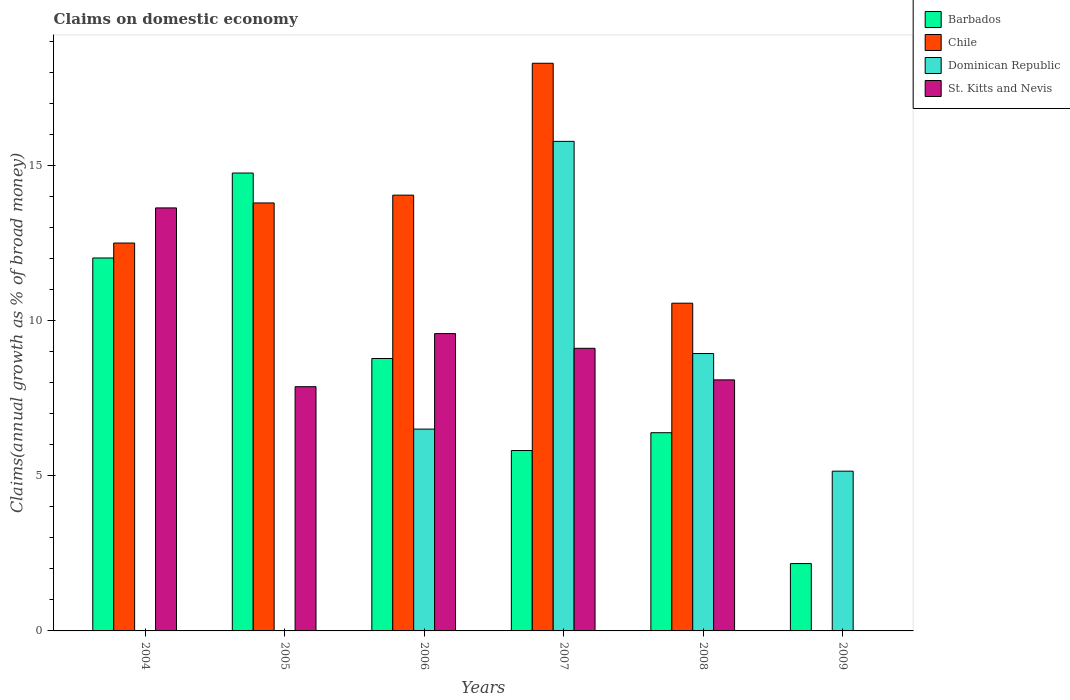Are the number of bars per tick equal to the number of legend labels?
Your answer should be compact. No. How many bars are there on the 5th tick from the left?
Provide a short and direct response. 4. How many bars are there on the 5th tick from the right?
Keep it short and to the point. 3. What is the percentage of broad money claimed on domestic economy in Barbados in 2004?
Ensure brevity in your answer.  12.03. Across all years, what is the maximum percentage of broad money claimed on domestic economy in St. Kitts and Nevis?
Give a very brief answer. 13.65. In which year was the percentage of broad money claimed on domestic economy in Dominican Republic maximum?
Your response must be concise. 2007. What is the total percentage of broad money claimed on domestic economy in Dominican Republic in the graph?
Offer a terse response. 36.4. What is the difference between the percentage of broad money claimed on domestic economy in Dominican Republic in 2007 and that in 2008?
Give a very brief answer. 6.84. What is the difference between the percentage of broad money claimed on domestic economy in Barbados in 2008 and the percentage of broad money claimed on domestic economy in Dominican Republic in 2009?
Provide a succinct answer. 1.24. What is the average percentage of broad money claimed on domestic economy in St. Kitts and Nevis per year?
Ensure brevity in your answer.  8.06. In the year 2004, what is the difference between the percentage of broad money claimed on domestic economy in Barbados and percentage of broad money claimed on domestic economy in Chile?
Ensure brevity in your answer.  -0.48. In how many years, is the percentage of broad money claimed on domestic economy in Dominican Republic greater than 2 %?
Ensure brevity in your answer.  4. What is the ratio of the percentage of broad money claimed on domestic economy in Chile in 2007 to that in 2008?
Offer a terse response. 1.73. Is the difference between the percentage of broad money claimed on domestic economy in Barbados in 2004 and 2005 greater than the difference between the percentage of broad money claimed on domestic economy in Chile in 2004 and 2005?
Provide a short and direct response. No. What is the difference between the highest and the second highest percentage of broad money claimed on domestic economy in St. Kitts and Nevis?
Your response must be concise. 4.05. What is the difference between the highest and the lowest percentage of broad money claimed on domestic economy in Barbados?
Offer a terse response. 12.6. In how many years, is the percentage of broad money claimed on domestic economy in Chile greater than the average percentage of broad money claimed on domestic economy in Chile taken over all years?
Give a very brief answer. 4. How many years are there in the graph?
Provide a succinct answer. 6. Are the values on the major ticks of Y-axis written in scientific E-notation?
Offer a terse response. No. Does the graph contain grids?
Make the answer very short. No. How many legend labels are there?
Your response must be concise. 4. What is the title of the graph?
Offer a terse response. Claims on domestic economy. Does "Thailand" appear as one of the legend labels in the graph?
Your response must be concise. No. What is the label or title of the X-axis?
Provide a succinct answer. Years. What is the label or title of the Y-axis?
Provide a short and direct response. Claims(annual growth as % of broad money). What is the Claims(annual growth as % of broad money) of Barbados in 2004?
Offer a terse response. 12.03. What is the Claims(annual growth as % of broad money) in Chile in 2004?
Provide a succinct answer. 12.51. What is the Claims(annual growth as % of broad money) in Dominican Republic in 2004?
Ensure brevity in your answer.  0. What is the Claims(annual growth as % of broad money) in St. Kitts and Nevis in 2004?
Your response must be concise. 13.65. What is the Claims(annual growth as % of broad money) in Barbados in 2005?
Give a very brief answer. 14.77. What is the Claims(annual growth as % of broad money) in Chile in 2005?
Offer a very short reply. 13.81. What is the Claims(annual growth as % of broad money) in St. Kitts and Nevis in 2005?
Make the answer very short. 7.88. What is the Claims(annual growth as % of broad money) in Barbados in 2006?
Give a very brief answer. 8.79. What is the Claims(annual growth as % of broad money) of Chile in 2006?
Keep it short and to the point. 14.06. What is the Claims(annual growth as % of broad money) in Dominican Republic in 2006?
Make the answer very short. 6.51. What is the Claims(annual growth as % of broad money) of St. Kitts and Nevis in 2006?
Provide a succinct answer. 9.59. What is the Claims(annual growth as % of broad money) of Barbados in 2007?
Your answer should be very brief. 5.82. What is the Claims(annual growth as % of broad money) of Chile in 2007?
Offer a very short reply. 18.31. What is the Claims(annual growth as % of broad money) of Dominican Republic in 2007?
Provide a succinct answer. 15.79. What is the Claims(annual growth as % of broad money) of St. Kitts and Nevis in 2007?
Keep it short and to the point. 9.12. What is the Claims(annual growth as % of broad money) in Barbados in 2008?
Make the answer very short. 6.39. What is the Claims(annual growth as % of broad money) of Chile in 2008?
Offer a terse response. 10.57. What is the Claims(annual growth as % of broad money) of Dominican Republic in 2008?
Offer a terse response. 8.95. What is the Claims(annual growth as % of broad money) in St. Kitts and Nevis in 2008?
Keep it short and to the point. 8.1. What is the Claims(annual growth as % of broad money) in Barbados in 2009?
Offer a very short reply. 2.17. What is the Claims(annual growth as % of broad money) of Dominican Republic in 2009?
Make the answer very short. 5.15. What is the Claims(annual growth as % of broad money) of St. Kitts and Nevis in 2009?
Keep it short and to the point. 0. Across all years, what is the maximum Claims(annual growth as % of broad money) in Barbados?
Make the answer very short. 14.77. Across all years, what is the maximum Claims(annual growth as % of broad money) in Chile?
Offer a very short reply. 18.31. Across all years, what is the maximum Claims(annual growth as % of broad money) in Dominican Republic?
Ensure brevity in your answer.  15.79. Across all years, what is the maximum Claims(annual growth as % of broad money) in St. Kitts and Nevis?
Keep it short and to the point. 13.65. Across all years, what is the minimum Claims(annual growth as % of broad money) in Barbados?
Your answer should be compact. 2.17. Across all years, what is the minimum Claims(annual growth as % of broad money) of Dominican Republic?
Your answer should be very brief. 0. Across all years, what is the minimum Claims(annual growth as % of broad money) in St. Kitts and Nevis?
Your response must be concise. 0. What is the total Claims(annual growth as % of broad money) of Barbados in the graph?
Provide a short and direct response. 49.97. What is the total Claims(annual growth as % of broad money) of Chile in the graph?
Give a very brief answer. 69.26. What is the total Claims(annual growth as % of broad money) in Dominican Republic in the graph?
Ensure brevity in your answer.  36.4. What is the total Claims(annual growth as % of broad money) of St. Kitts and Nevis in the graph?
Ensure brevity in your answer.  48.33. What is the difference between the Claims(annual growth as % of broad money) of Barbados in 2004 and that in 2005?
Keep it short and to the point. -2.74. What is the difference between the Claims(annual growth as % of broad money) in Chile in 2004 and that in 2005?
Your response must be concise. -1.29. What is the difference between the Claims(annual growth as % of broad money) in St. Kitts and Nevis in 2004 and that in 2005?
Your answer should be very brief. 5.77. What is the difference between the Claims(annual growth as % of broad money) of Barbados in 2004 and that in 2006?
Provide a succinct answer. 3.24. What is the difference between the Claims(annual growth as % of broad money) in Chile in 2004 and that in 2006?
Give a very brief answer. -1.54. What is the difference between the Claims(annual growth as % of broad money) in St. Kitts and Nevis in 2004 and that in 2006?
Ensure brevity in your answer.  4.05. What is the difference between the Claims(annual growth as % of broad money) in Barbados in 2004 and that in 2007?
Keep it short and to the point. 6.21. What is the difference between the Claims(annual growth as % of broad money) of Chile in 2004 and that in 2007?
Make the answer very short. -5.8. What is the difference between the Claims(annual growth as % of broad money) in St. Kitts and Nevis in 2004 and that in 2007?
Your answer should be compact. 4.53. What is the difference between the Claims(annual growth as % of broad money) in Barbados in 2004 and that in 2008?
Provide a short and direct response. 5.64. What is the difference between the Claims(annual growth as % of broad money) of Chile in 2004 and that in 2008?
Provide a succinct answer. 1.94. What is the difference between the Claims(annual growth as % of broad money) of St. Kitts and Nevis in 2004 and that in 2008?
Ensure brevity in your answer.  5.55. What is the difference between the Claims(annual growth as % of broad money) of Barbados in 2004 and that in 2009?
Provide a short and direct response. 9.86. What is the difference between the Claims(annual growth as % of broad money) of Barbados in 2005 and that in 2006?
Give a very brief answer. 5.98. What is the difference between the Claims(annual growth as % of broad money) in Chile in 2005 and that in 2006?
Ensure brevity in your answer.  -0.25. What is the difference between the Claims(annual growth as % of broad money) of St. Kitts and Nevis in 2005 and that in 2006?
Give a very brief answer. -1.71. What is the difference between the Claims(annual growth as % of broad money) in Barbados in 2005 and that in 2007?
Offer a terse response. 8.95. What is the difference between the Claims(annual growth as % of broad money) of Chile in 2005 and that in 2007?
Your response must be concise. -4.51. What is the difference between the Claims(annual growth as % of broad money) in St. Kitts and Nevis in 2005 and that in 2007?
Give a very brief answer. -1.24. What is the difference between the Claims(annual growth as % of broad money) of Barbados in 2005 and that in 2008?
Give a very brief answer. 8.38. What is the difference between the Claims(annual growth as % of broad money) of Chile in 2005 and that in 2008?
Your answer should be very brief. 3.23. What is the difference between the Claims(annual growth as % of broad money) of St. Kitts and Nevis in 2005 and that in 2008?
Provide a short and direct response. -0.22. What is the difference between the Claims(annual growth as % of broad money) in Barbados in 2005 and that in 2009?
Offer a very short reply. 12.6. What is the difference between the Claims(annual growth as % of broad money) in Barbados in 2006 and that in 2007?
Your response must be concise. 2.97. What is the difference between the Claims(annual growth as % of broad money) in Chile in 2006 and that in 2007?
Provide a succinct answer. -4.25. What is the difference between the Claims(annual growth as % of broad money) of Dominican Republic in 2006 and that in 2007?
Your answer should be very brief. -9.28. What is the difference between the Claims(annual growth as % of broad money) of St. Kitts and Nevis in 2006 and that in 2007?
Provide a short and direct response. 0.47. What is the difference between the Claims(annual growth as % of broad money) of Barbados in 2006 and that in 2008?
Give a very brief answer. 2.39. What is the difference between the Claims(annual growth as % of broad money) of Chile in 2006 and that in 2008?
Keep it short and to the point. 3.49. What is the difference between the Claims(annual growth as % of broad money) of Dominican Republic in 2006 and that in 2008?
Make the answer very short. -2.44. What is the difference between the Claims(annual growth as % of broad money) in St. Kitts and Nevis in 2006 and that in 2008?
Provide a short and direct response. 1.49. What is the difference between the Claims(annual growth as % of broad money) of Barbados in 2006 and that in 2009?
Make the answer very short. 6.61. What is the difference between the Claims(annual growth as % of broad money) in Dominican Republic in 2006 and that in 2009?
Offer a terse response. 1.36. What is the difference between the Claims(annual growth as % of broad money) in Barbados in 2007 and that in 2008?
Make the answer very short. -0.57. What is the difference between the Claims(annual growth as % of broad money) of Chile in 2007 and that in 2008?
Ensure brevity in your answer.  7.74. What is the difference between the Claims(annual growth as % of broad money) in Dominican Republic in 2007 and that in 2008?
Your answer should be very brief. 6.84. What is the difference between the Claims(annual growth as % of broad money) in St. Kitts and Nevis in 2007 and that in 2008?
Provide a succinct answer. 1.02. What is the difference between the Claims(annual growth as % of broad money) in Barbados in 2007 and that in 2009?
Make the answer very short. 3.65. What is the difference between the Claims(annual growth as % of broad money) in Dominican Republic in 2007 and that in 2009?
Your answer should be very brief. 10.64. What is the difference between the Claims(annual growth as % of broad money) in Barbados in 2008 and that in 2009?
Your answer should be compact. 4.22. What is the difference between the Claims(annual growth as % of broad money) of Dominican Republic in 2008 and that in 2009?
Ensure brevity in your answer.  3.79. What is the difference between the Claims(annual growth as % of broad money) in Barbados in 2004 and the Claims(annual growth as % of broad money) in Chile in 2005?
Ensure brevity in your answer.  -1.78. What is the difference between the Claims(annual growth as % of broad money) in Barbados in 2004 and the Claims(annual growth as % of broad money) in St. Kitts and Nevis in 2005?
Keep it short and to the point. 4.15. What is the difference between the Claims(annual growth as % of broad money) in Chile in 2004 and the Claims(annual growth as % of broad money) in St. Kitts and Nevis in 2005?
Provide a succinct answer. 4.63. What is the difference between the Claims(annual growth as % of broad money) in Barbados in 2004 and the Claims(annual growth as % of broad money) in Chile in 2006?
Provide a succinct answer. -2.03. What is the difference between the Claims(annual growth as % of broad money) in Barbados in 2004 and the Claims(annual growth as % of broad money) in Dominican Republic in 2006?
Keep it short and to the point. 5.52. What is the difference between the Claims(annual growth as % of broad money) of Barbados in 2004 and the Claims(annual growth as % of broad money) of St. Kitts and Nevis in 2006?
Ensure brevity in your answer.  2.44. What is the difference between the Claims(annual growth as % of broad money) in Chile in 2004 and the Claims(annual growth as % of broad money) in Dominican Republic in 2006?
Keep it short and to the point. 6. What is the difference between the Claims(annual growth as % of broad money) in Chile in 2004 and the Claims(annual growth as % of broad money) in St. Kitts and Nevis in 2006?
Keep it short and to the point. 2.92. What is the difference between the Claims(annual growth as % of broad money) of Barbados in 2004 and the Claims(annual growth as % of broad money) of Chile in 2007?
Provide a succinct answer. -6.28. What is the difference between the Claims(annual growth as % of broad money) of Barbados in 2004 and the Claims(annual growth as % of broad money) of Dominican Republic in 2007?
Your response must be concise. -3.76. What is the difference between the Claims(annual growth as % of broad money) of Barbados in 2004 and the Claims(annual growth as % of broad money) of St. Kitts and Nevis in 2007?
Keep it short and to the point. 2.91. What is the difference between the Claims(annual growth as % of broad money) in Chile in 2004 and the Claims(annual growth as % of broad money) in Dominican Republic in 2007?
Provide a short and direct response. -3.28. What is the difference between the Claims(annual growth as % of broad money) in Chile in 2004 and the Claims(annual growth as % of broad money) in St. Kitts and Nevis in 2007?
Ensure brevity in your answer.  3.4. What is the difference between the Claims(annual growth as % of broad money) of Barbados in 2004 and the Claims(annual growth as % of broad money) of Chile in 2008?
Your answer should be compact. 1.46. What is the difference between the Claims(annual growth as % of broad money) in Barbados in 2004 and the Claims(annual growth as % of broad money) in Dominican Republic in 2008?
Your answer should be compact. 3.08. What is the difference between the Claims(annual growth as % of broad money) of Barbados in 2004 and the Claims(annual growth as % of broad money) of St. Kitts and Nevis in 2008?
Offer a terse response. 3.93. What is the difference between the Claims(annual growth as % of broad money) in Chile in 2004 and the Claims(annual growth as % of broad money) in Dominican Republic in 2008?
Offer a very short reply. 3.56. What is the difference between the Claims(annual growth as % of broad money) in Chile in 2004 and the Claims(annual growth as % of broad money) in St. Kitts and Nevis in 2008?
Your answer should be very brief. 4.41. What is the difference between the Claims(annual growth as % of broad money) of Barbados in 2004 and the Claims(annual growth as % of broad money) of Dominican Republic in 2009?
Provide a succinct answer. 6.88. What is the difference between the Claims(annual growth as % of broad money) of Chile in 2004 and the Claims(annual growth as % of broad money) of Dominican Republic in 2009?
Your answer should be compact. 7.36. What is the difference between the Claims(annual growth as % of broad money) of Barbados in 2005 and the Claims(annual growth as % of broad money) of Chile in 2006?
Keep it short and to the point. 0.71. What is the difference between the Claims(annual growth as % of broad money) in Barbados in 2005 and the Claims(annual growth as % of broad money) in Dominican Republic in 2006?
Offer a terse response. 8.26. What is the difference between the Claims(annual growth as % of broad money) in Barbados in 2005 and the Claims(annual growth as % of broad money) in St. Kitts and Nevis in 2006?
Your response must be concise. 5.18. What is the difference between the Claims(annual growth as % of broad money) of Chile in 2005 and the Claims(annual growth as % of broad money) of Dominican Republic in 2006?
Your response must be concise. 7.3. What is the difference between the Claims(annual growth as % of broad money) of Chile in 2005 and the Claims(annual growth as % of broad money) of St. Kitts and Nevis in 2006?
Offer a terse response. 4.21. What is the difference between the Claims(annual growth as % of broad money) of Barbados in 2005 and the Claims(annual growth as % of broad money) of Chile in 2007?
Give a very brief answer. -3.54. What is the difference between the Claims(annual growth as % of broad money) in Barbados in 2005 and the Claims(annual growth as % of broad money) in Dominican Republic in 2007?
Your answer should be compact. -1.02. What is the difference between the Claims(annual growth as % of broad money) of Barbados in 2005 and the Claims(annual growth as % of broad money) of St. Kitts and Nevis in 2007?
Provide a succinct answer. 5.65. What is the difference between the Claims(annual growth as % of broad money) of Chile in 2005 and the Claims(annual growth as % of broad money) of Dominican Republic in 2007?
Give a very brief answer. -1.99. What is the difference between the Claims(annual growth as % of broad money) in Chile in 2005 and the Claims(annual growth as % of broad money) in St. Kitts and Nevis in 2007?
Provide a short and direct response. 4.69. What is the difference between the Claims(annual growth as % of broad money) in Barbados in 2005 and the Claims(annual growth as % of broad money) in Chile in 2008?
Make the answer very short. 4.2. What is the difference between the Claims(annual growth as % of broad money) in Barbados in 2005 and the Claims(annual growth as % of broad money) in Dominican Republic in 2008?
Ensure brevity in your answer.  5.82. What is the difference between the Claims(annual growth as % of broad money) of Barbados in 2005 and the Claims(annual growth as % of broad money) of St. Kitts and Nevis in 2008?
Offer a terse response. 6.67. What is the difference between the Claims(annual growth as % of broad money) of Chile in 2005 and the Claims(annual growth as % of broad money) of Dominican Republic in 2008?
Give a very brief answer. 4.86. What is the difference between the Claims(annual growth as % of broad money) of Chile in 2005 and the Claims(annual growth as % of broad money) of St. Kitts and Nevis in 2008?
Provide a succinct answer. 5.71. What is the difference between the Claims(annual growth as % of broad money) in Barbados in 2005 and the Claims(annual growth as % of broad money) in Dominican Republic in 2009?
Offer a terse response. 9.62. What is the difference between the Claims(annual growth as % of broad money) of Chile in 2005 and the Claims(annual growth as % of broad money) of Dominican Republic in 2009?
Offer a very short reply. 8.65. What is the difference between the Claims(annual growth as % of broad money) in Barbados in 2006 and the Claims(annual growth as % of broad money) in Chile in 2007?
Your response must be concise. -9.52. What is the difference between the Claims(annual growth as % of broad money) in Barbados in 2006 and the Claims(annual growth as % of broad money) in Dominican Republic in 2007?
Ensure brevity in your answer.  -7. What is the difference between the Claims(annual growth as % of broad money) of Barbados in 2006 and the Claims(annual growth as % of broad money) of St. Kitts and Nevis in 2007?
Your answer should be very brief. -0.33. What is the difference between the Claims(annual growth as % of broad money) of Chile in 2006 and the Claims(annual growth as % of broad money) of Dominican Republic in 2007?
Ensure brevity in your answer.  -1.73. What is the difference between the Claims(annual growth as % of broad money) in Chile in 2006 and the Claims(annual growth as % of broad money) in St. Kitts and Nevis in 2007?
Make the answer very short. 4.94. What is the difference between the Claims(annual growth as % of broad money) of Dominican Republic in 2006 and the Claims(annual growth as % of broad money) of St. Kitts and Nevis in 2007?
Your answer should be very brief. -2.61. What is the difference between the Claims(annual growth as % of broad money) of Barbados in 2006 and the Claims(annual growth as % of broad money) of Chile in 2008?
Provide a short and direct response. -1.78. What is the difference between the Claims(annual growth as % of broad money) in Barbados in 2006 and the Claims(annual growth as % of broad money) in Dominican Republic in 2008?
Give a very brief answer. -0.16. What is the difference between the Claims(annual growth as % of broad money) of Barbados in 2006 and the Claims(annual growth as % of broad money) of St. Kitts and Nevis in 2008?
Provide a succinct answer. 0.69. What is the difference between the Claims(annual growth as % of broad money) in Chile in 2006 and the Claims(annual growth as % of broad money) in Dominican Republic in 2008?
Your response must be concise. 5.11. What is the difference between the Claims(annual growth as % of broad money) of Chile in 2006 and the Claims(annual growth as % of broad money) of St. Kitts and Nevis in 2008?
Provide a succinct answer. 5.96. What is the difference between the Claims(annual growth as % of broad money) of Dominican Republic in 2006 and the Claims(annual growth as % of broad money) of St. Kitts and Nevis in 2008?
Make the answer very short. -1.59. What is the difference between the Claims(annual growth as % of broad money) in Barbados in 2006 and the Claims(annual growth as % of broad money) in Dominican Republic in 2009?
Make the answer very short. 3.63. What is the difference between the Claims(annual growth as % of broad money) of Chile in 2006 and the Claims(annual growth as % of broad money) of Dominican Republic in 2009?
Ensure brevity in your answer.  8.9. What is the difference between the Claims(annual growth as % of broad money) in Barbados in 2007 and the Claims(annual growth as % of broad money) in Chile in 2008?
Provide a short and direct response. -4.75. What is the difference between the Claims(annual growth as % of broad money) of Barbados in 2007 and the Claims(annual growth as % of broad money) of Dominican Republic in 2008?
Make the answer very short. -3.13. What is the difference between the Claims(annual growth as % of broad money) in Barbados in 2007 and the Claims(annual growth as % of broad money) in St. Kitts and Nevis in 2008?
Your answer should be compact. -2.28. What is the difference between the Claims(annual growth as % of broad money) of Chile in 2007 and the Claims(annual growth as % of broad money) of Dominican Republic in 2008?
Make the answer very short. 9.36. What is the difference between the Claims(annual growth as % of broad money) in Chile in 2007 and the Claims(annual growth as % of broad money) in St. Kitts and Nevis in 2008?
Give a very brief answer. 10.21. What is the difference between the Claims(annual growth as % of broad money) in Dominican Republic in 2007 and the Claims(annual growth as % of broad money) in St. Kitts and Nevis in 2008?
Keep it short and to the point. 7.69. What is the difference between the Claims(annual growth as % of broad money) of Barbados in 2007 and the Claims(annual growth as % of broad money) of Dominican Republic in 2009?
Offer a very short reply. 0.67. What is the difference between the Claims(annual growth as % of broad money) in Chile in 2007 and the Claims(annual growth as % of broad money) in Dominican Republic in 2009?
Provide a succinct answer. 13.16. What is the difference between the Claims(annual growth as % of broad money) of Barbados in 2008 and the Claims(annual growth as % of broad money) of Dominican Republic in 2009?
Offer a terse response. 1.24. What is the difference between the Claims(annual growth as % of broad money) of Chile in 2008 and the Claims(annual growth as % of broad money) of Dominican Republic in 2009?
Make the answer very short. 5.42. What is the average Claims(annual growth as % of broad money) in Barbados per year?
Your answer should be compact. 8.33. What is the average Claims(annual growth as % of broad money) of Chile per year?
Offer a very short reply. 11.54. What is the average Claims(annual growth as % of broad money) of Dominican Republic per year?
Make the answer very short. 6.07. What is the average Claims(annual growth as % of broad money) in St. Kitts and Nevis per year?
Offer a terse response. 8.06. In the year 2004, what is the difference between the Claims(annual growth as % of broad money) in Barbados and Claims(annual growth as % of broad money) in Chile?
Keep it short and to the point. -0.48. In the year 2004, what is the difference between the Claims(annual growth as % of broad money) in Barbados and Claims(annual growth as % of broad money) in St. Kitts and Nevis?
Give a very brief answer. -1.62. In the year 2004, what is the difference between the Claims(annual growth as % of broad money) in Chile and Claims(annual growth as % of broad money) in St. Kitts and Nevis?
Provide a succinct answer. -1.13. In the year 2005, what is the difference between the Claims(annual growth as % of broad money) of Barbados and Claims(annual growth as % of broad money) of Chile?
Make the answer very short. 0.96. In the year 2005, what is the difference between the Claims(annual growth as % of broad money) in Barbados and Claims(annual growth as % of broad money) in St. Kitts and Nevis?
Ensure brevity in your answer.  6.89. In the year 2005, what is the difference between the Claims(annual growth as % of broad money) of Chile and Claims(annual growth as % of broad money) of St. Kitts and Nevis?
Provide a short and direct response. 5.93. In the year 2006, what is the difference between the Claims(annual growth as % of broad money) in Barbados and Claims(annual growth as % of broad money) in Chile?
Ensure brevity in your answer.  -5.27. In the year 2006, what is the difference between the Claims(annual growth as % of broad money) in Barbados and Claims(annual growth as % of broad money) in Dominican Republic?
Offer a very short reply. 2.28. In the year 2006, what is the difference between the Claims(annual growth as % of broad money) in Barbados and Claims(annual growth as % of broad money) in St. Kitts and Nevis?
Provide a succinct answer. -0.8. In the year 2006, what is the difference between the Claims(annual growth as % of broad money) in Chile and Claims(annual growth as % of broad money) in Dominican Republic?
Offer a very short reply. 7.55. In the year 2006, what is the difference between the Claims(annual growth as % of broad money) in Chile and Claims(annual growth as % of broad money) in St. Kitts and Nevis?
Offer a very short reply. 4.47. In the year 2006, what is the difference between the Claims(annual growth as % of broad money) of Dominican Republic and Claims(annual growth as % of broad money) of St. Kitts and Nevis?
Give a very brief answer. -3.08. In the year 2007, what is the difference between the Claims(annual growth as % of broad money) in Barbados and Claims(annual growth as % of broad money) in Chile?
Your response must be concise. -12.49. In the year 2007, what is the difference between the Claims(annual growth as % of broad money) in Barbados and Claims(annual growth as % of broad money) in Dominican Republic?
Your answer should be compact. -9.97. In the year 2007, what is the difference between the Claims(annual growth as % of broad money) in Barbados and Claims(annual growth as % of broad money) in St. Kitts and Nevis?
Offer a very short reply. -3.3. In the year 2007, what is the difference between the Claims(annual growth as % of broad money) in Chile and Claims(annual growth as % of broad money) in Dominican Republic?
Offer a very short reply. 2.52. In the year 2007, what is the difference between the Claims(annual growth as % of broad money) in Chile and Claims(annual growth as % of broad money) in St. Kitts and Nevis?
Provide a short and direct response. 9.2. In the year 2007, what is the difference between the Claims(annual growth as % of broad money) of Dominican Republic and Claims(annual growth as % of broad money) of St. Kitts and Nevis?
Provide a short and direct response. 6.68. In the year 2008, what is the difference between the Claims(annual growth as % of broad money) in Barbados and Claims(annual growth as % of broad money) in Chile?
Keep it short and to the point. -4.18. In the year 2008, what is the difference between the Claims(annual growth as % of broad money) of Barbados and Claims(annual growth as % of broad money) of Dominican Republic?
Your answer should be very brief. -2.55. In the year 2008, what is the difference between the Claims(annual growth as % of broad money) in Barbados and Claims(annual growth as % of broad money) in St. Kitts and Nevis?
Your answer should be very brief. -1.7. In the year 2008, what is the difference between the Claims(annual growth as % of broad money) of Chile and Claims(annual growth as % of broad money) of Dominican Republic?
Your response must be concise. 1.62. In the year 2008, what is the difference between the Claims(annual growth as % of broad money) of Chile and Claims(annual growth as % of broad money) of St. Kitts and Nevis?
Make the answer very short. 2.47. In the year 2008, what is the difference between the Claims(annual growth as % of broad money) of Dominican Republic and Claims(annual growth as % of broad money) of St. Kitts and Nevis?
Your answer should be very brief. 0.85. In the year 2009, what is the difference between the Claims(annual growth as % of broad money) in Barbados and Claims(annual growth as % of broad money) in Dominican Republic?
Provide a succinct answer. -2.98. What is the ratio of the Claims(annual growth as % of broad money) of Barbados in 2004 to that in 2005?
Ensure brevity in your answer.  0.81. What is the ratio of the Claims(annual growth as % of broad money) of Chile in 2004 to that in 2005?
Give a very brief answer. 0.91. What is the ratio of the Claims(annual growth as % of broad money) of St. Kitts and Nevis in 2004 to that in 2005?
Give a very brief answer. 1.73. What is the ratio of the Claims(annual growth as % of broad money) of Barbados in 2004 to that in 2006?
Ensure brevity in your answer.  1.37. What is the ratio of the Claims(annual growth as % of broad money) of Chile in 2004 to that in 2006?
Your answer should be very brief. 0.89. What is the ratio of the Claims(annual growth as % of broad money) of St. Kitts and Nevis in 2004 to that in 2006?
Your answer should be compact. 1.42. What is the ratio of the Claims(annual growth as % of broad money) of Barbados in 2004 to that in 2007?
Offer a very short reply. 2.07. What is the ratio of the Claims(annual growth as % of broad money) of Chile in 2004 to that in 2007?
Give a very brief answer. 0.68. What is the ratio of the Claims(annual growth as % of broad money) of St. Kitts and Nevis in 2004 to that in 2007?
Make the answer very short. 1.5. What is the ratio of the Claims(annual growth as % of broad money) of Barbados in 2004 to that in 2008?
Provide a short and direct response. 1.88. What is the ratio of the Claims(annual growth as % of broad money) of Chile in 2004 to that in 2008?
Your response must be concise. 1.18. What is the ratio of the Claims(annual growth as % of broad money) of St. Kitts and Nevis in 2004 to that in 2008?
Offer a very short reply. 1.69. What is the ratio of the Claims(annual growth as % of broad money) of Barbados in 2004 to that in 2009?
Ensure brevity in your answer.  5.54. What is the ratio of the Claims(annual growth as % of broad money) in Barbados in 2005 to that in 2006?
Provide a succinct answer. 1.68. What is the ratio of the Claims(annual growth as % of broad money) of Chile in 2005 to that in 2006?
Make the answer very short. 0.98. What is the ratio of the Claims(annual growth as % of broad money) in St. Kitts and Nevis in 2005 to that in 2006?
Provide a succinct answer. 0.82. What is the ratio of the Claims(annual growth as % of broad money) in Barbados in 2005 to that in 2007?
Make the answer very short. 2.54. What is the ratio of the Claims(annual growth as % of broad money) of Chile in 2005 to that in 2007?
Give a very brief answer. 0.75. What is the ratio of the Claims(annual growth as % of broad money) of St. Kitts and Nevis in 2005 to that in 2007?
Keep it short and to the point. 0.86. What is the ratio of the Claims(annual growth as % of broad money) in Barbados in 2005 to that in 2008?
Ensure brevity in your answer.  2.31. What is the ratio of the Claims(annual growth as % of broad money) in Chile in 2005 to that in 2008?
Your answer should be compact. 1.31. What is the ratio of the Claims(annual growth as % of broad money) of St. Kitts and Nevis in 2005 to that in 2008?
Your answer should be very brief. 0.97. What is the ratio of the Claims(annual growth as % of broad money) in Barbados in 2005 to that in 2009?
Your response must be concise. 6.8. What is the ratio of the Claims(annual growth as % of broad money) of Barbados in 2006 to that in 2007?
Offer a very short reply. 1.51. What is the ratio of the Claims(annual growth as % of broad money) of Chile in 2006 to that in 2007?
Make the answer very short. 0.77. What is the ratio of the Claims(annual growth as % of broad money) of Dominican Republic in 2006 to that in 2007?
Offer a terse response. 0.41. What is the ratio of the Claims(annual growth as % of broad money) of St. Kitts and Nevis in 2006 to that in 2007?
Your answer should be very brief. 1.05. What is the ratio of the Claims(annual growth as % of broad money) of Barbados in 2006 to that in 2008?
Your answer should be compact. 1.37. What is the ratio of the Claims(annual growth as % of broad money) of Chile in 2006 to that in 2008?
Your answer should be very brief. 1.33. What is the ratio of the Claims(annual growth as % of broad money) of Dominican Republic in 2006 to that in 2008?
Ensure brevity in your answer.  0.73. What is the ratio of the Claims(annual growth as % of broad money) of St. Kitts and Nevis in 2006 to that in 2008?
Offer a very short reply. 1.18. What is the ratio of the Claims(annual growth as % of broad money) of Barbados in 2006 to that in 2009?
Make the answer very short. 4.04. What is the ratio of the Claims(annual growth as % of broad money) of Dominican Republic in 2006 to that in 2009?
Offer a terse response. 1.26. What is the ratio of the Claims(annual growth as % of broad money) in Barbados in 2007 to that in 2008?
Offer a very short reply. 0.91. What is the ratio of the Claims(annual growth as % of broad money) in Chile in 2007 to that in 2008?
Ensure brevity in your answer.  1.73. What is the ratio of the Claims(annual growth as % of broad money) of Dominican Republic in 2007 to that in 2008?
Provide a succinct answer. 1.76. What is the ratio of the Claims(annual growth as % of broad money) in St. Kitts and Nevis in 2007 to that in 2008?
Keep it short and to the point. 1.13. What is the ratio of the Claims(annual growth as % of broad money) of Barbados in 2007 to that in 2009?
Keep it short and to the point. 2.68. What is the ratio of the Claims(annual growth as % of broad money) in Dominican Republic in 2007 to that in 2009?
Offer a terse response. 3.06. What is the ratio of the Claims(annual growth as % of broad money) of Barbados in 2008 to that in 2009?
Provide a short and direct response. 2.94. What is the ratio of the Claims(annual growth as % of broad money) in Dominican Republic in 2008 to that in 2009?
Your response must be concise. 1.74. What is the difference between the highest and the second highest Claims(annual growth as % of broad money) of Barbados?
Provide a short and direct response. 2.74. What is the difference between the highest and the second highest Claims(annual growth as % of broad money) of Chile?
Keep it short and to the point. 4.25. What is the difference between the highest and the second highest Claims(annual growth as % of broad money) in Dominican Republic?
Provide a short and direct response. 6.84. What is the difference between the highest and the second highest Claims(annual growth as % of broad money) of St. Kitts and Nevis?
Give a very brief answer. 4.05. What is the difference between the highest and the lowest Claims(annual growth as % of broad money) of Barbados?
Provide a succinct answer. 12.6. What is the difference between the highest and the lowest Claims(annual growth as % of broad money) of Chile?
Give a very brief answer. 18.31. What is the difference between the highest and the lowest Claims(annual growth as % of broad money) in Dominican Republic?
Give a very brief answer. 15.79. What is the difference between the highest and the lowest Claims(annual growth as % of broad money) of St. Kitts and Nevis?
Give a very brief answer. 13.65. 